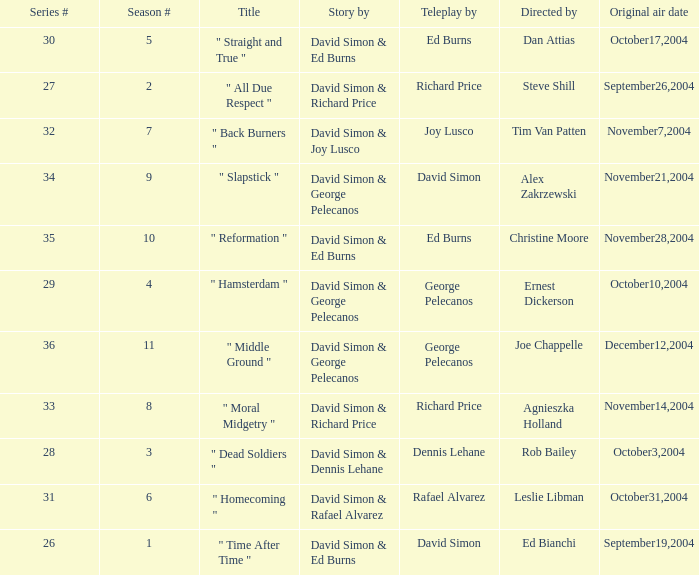What is the total number of values for "Teleplay by" category for series # 35? 1.0. 